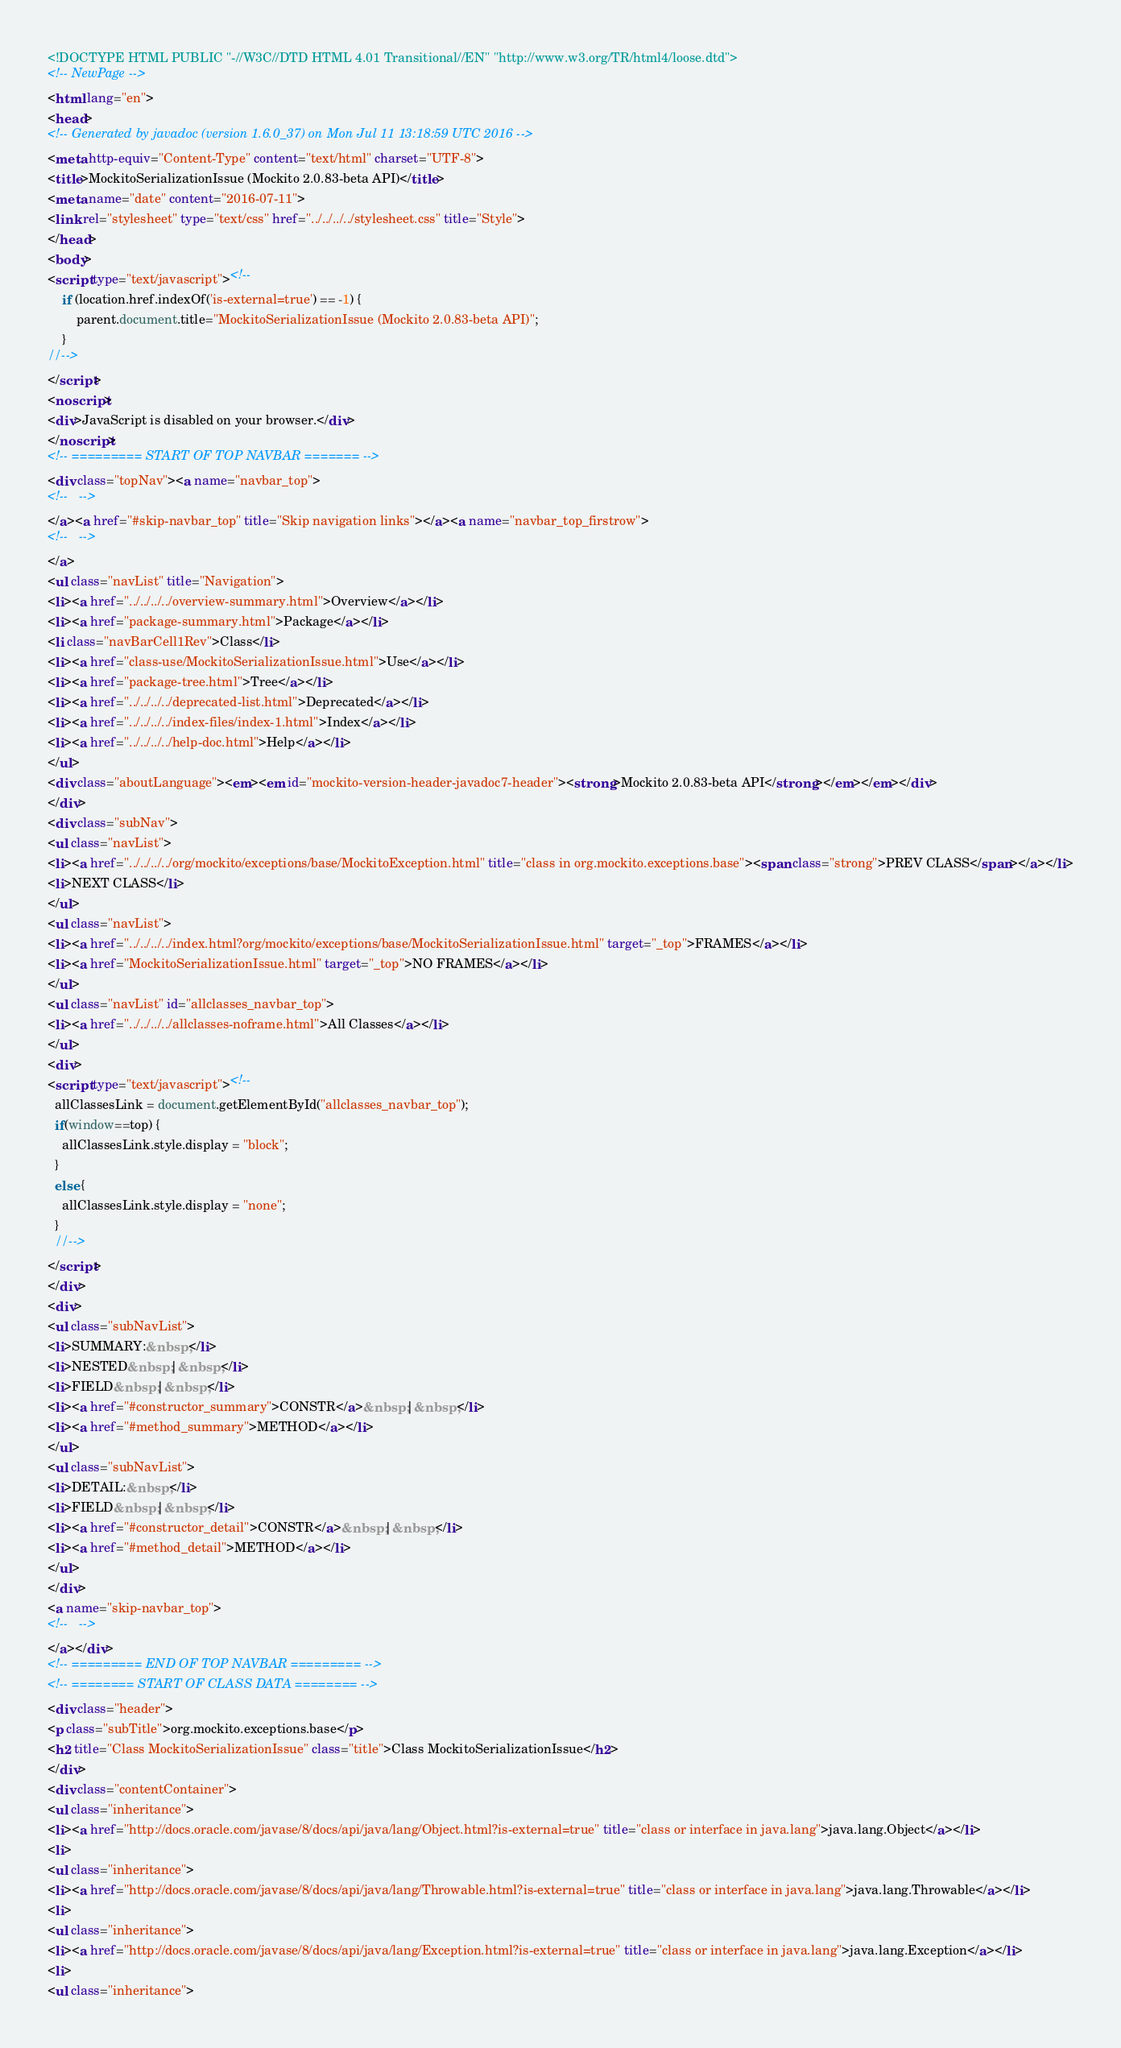Convert code to text. <code><loc_0><loc_0><loc_500><loc_500><_HTML_><!DOCTYPE HTML PUBLIC "-//W3C//DTD HTML 4.01 Transitional//EN" "http://www.w3.org/TR/html4/loose.dtd">
<!-- NewPage -->
<html lang="en">
<head>
<!-- Generated by javadoc (version 1.6.0_37) on Mon Jul 11 13:18:59 UTC 2016 -->
<meta http-equiv="Content-Type" content="text/html" charset="UTF-8">
<title>MockitoSerializationIssue (Mockito 2.0.83-beta API)</title>
<meta name="date" content="2016-07-11">
<link rel="stylesheet" type="text/css" href="../../../../stylesheet.css" title="Style">
</head>
<body>
<script type="text/javascript"><!--
    if (location.href.indexOf('is-external=true') == -1) {
        parent.document.title="MockitoSerializationIssue (Mockito 2.0.83-beta API)";
    }
//-->
</script>
<noscript>
<div>JavaScript is disabled on your browser.</div>
</noscript>
<!-- ========= START OF TOP NAVBAR ======= -->
<div class="topNav"><a name="navbar_top">
<!--   -->
</a><a href="#skip-navbar_top" title="Skip navigation links"></a><a name="navbar_top_firstrow">
<!--   -->
</a>
<ul class="navList" title="Navigation">
<li><a href="../../../../overview-summary.html">Overview</a></li>
<li><a href="package-summary.html">Package</a></li>
<li class="navBarCell1Rev">Class</li>
<li><a href="class-use/MockitoSerializationIssue.html">Use</a></li>
<li><a href="package-tree.html">Tree</a></li>
<li><a href="../../../../deprecated-list.html">Deprecated</a></li>
<li><a href="../../../../index-files/index-1.html">Index</a></li>
<li><a href="../../../../help-doc.html">Help</a></li>
</ul>
<div class="aboutLanguage"><em><em id="mockito-version-header-javadoc7-header"><strong>Mockito 2.0.83-beta API</strong></em></em></div>
</div>
<div class="subNav">
<ul class="navList">
<li><a href="../../../../org/mockito/exceptions/base/MockitoException.html" title="class in org.mockito.exceptions.base"><span class="strong">PREV CLASS</span></a></li>
<li>NEXT CLASS</li>
</ul>
<ul class="navList">
<li><a href="../../../../index.html?org/mockito/exceptions/base/MockitoSerializationIssue.html" target="_top">FRAMES</a></li>
<li><a href="MockitoSerializationIssue.html" target="_top">NO FRAMES</a></li>
</ul>
<ul class="navList" id="allclasses_navbar_top">
<li><a href="../../../../allclasses-noframe.html">All Classes</a></li>
</ul>
<div>
<script type="text/javascript"><!--
  allClassesLink = document.getElementById("allclasses_navbar_top");
  if(window==top) {
    allClassesLink.style.display = "block";
  }
  else {
    allClassesLink.style.display = "none";
  }
  //-->
</script>
</div>
<div>
<ul class="subNavList">
<li>SUMMARY:&nbsp;</li>
<li>NESTED&nbsp;|&nbsp;</li>
<li>FIELD&nbsp;|&nbsp;</li>
<li><a href="#constructor_summary">CONSTR</a>&nbsp;|&nbsp;</li>
<li><a href="#method_summary">METHOD</a></li>
</ul>
<ul class="subNavList">
<li>DETAIL:&nbsp;</li>
<li>FIELD&nbsp;|&nbsp;</li>
<li><a href="#constructor_detail">CONSTR</a>&nbsp;|&nbsp;</li>
<li><a href="#method_detail">METHOD</a></li>
</ul>
</div>
<a name="skip-navbar_top">
<!--   -->
</a></div>
<!-- ========= END OF TOP NAVBAR ========= -->
<!-- ======== START OF CLASS DATA ======== -->
<div class="header">
<p class="subTitle">org.mockito.exceptions.base</p>
<h2 title="Class MockitoSerializationIssue" class="title">Class MockitoSerializationIssue</h2>
</div>
<div class="contentContainer">
<ul class="inheritance">
<li><a href="http://docs.oracle.com/javase/8/docs/api/java/lang/Object.html?is-external=true" title="class or interface in java.lang">java.lang.Object</a></li>
<li>
<ul class="inheritance">
<li><a href="http://docs.oracle.com/javase/8/docs/api/java/lang/Throwable.html?is-external=true" title="class or interface in java.lang">java.lang.Throwable</a></li>
<li>
<ul class="inheritance">
<li><a href="http://docs.oracle.com/javase/8/docs/api/java/lang/Exception.html?is-external=true" title="class or interface in java.lang">java.lang.Exception</a></li>
<li>
<ul class="inheritance"></code> 